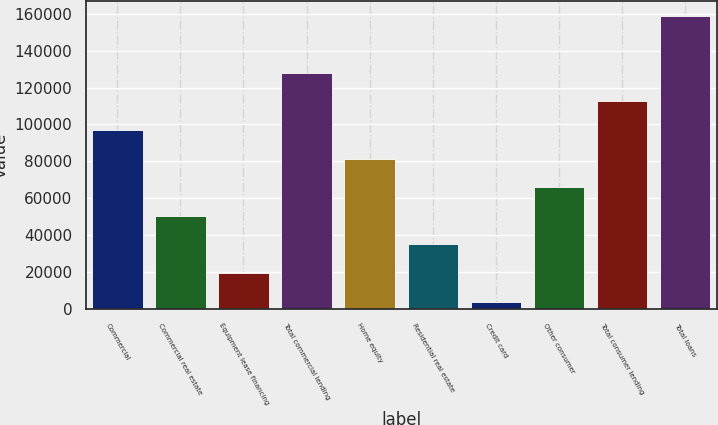Convert chart to OTSL. <chart><loc_0><loc_0><loc_500><loc_500><bar_chart><fcel>Commercial<fcel>Commercial real estate<fcel>Equipment lease financing<fcel>Total commercial lending<fcel>Home equity<fcel>Residential real estate<fcel>Credit card<fcel>Other consumer<fcel>Total consumer lending<fcel>Total loans<nl><fcel>96998.8<fcel>50487.4<fcel>19479.8<fcel>128006<fcel>81495<fcel>34983.6<fcel>3976<fcel>65991.2<fcel>112503<fcel>159014<nl></chart> 